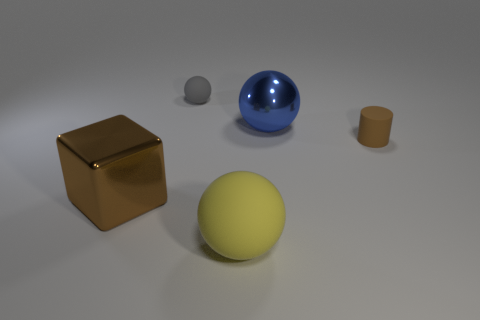Add 2 purple cylinders. How many objects exist? 7 Subtract all spheres. How many objects are left? 2 Subtract 0 purple spheres. How many objects are left? 5 Subtract all yellow metallic balls. Subtract all small brown cylinders. How many objects are left? 4 Add 4 brown rubber cylinders. How many brown rubber cylinders are left? 5 Add 5 cyan metal objects. How many cyan metal objects exist? 5 